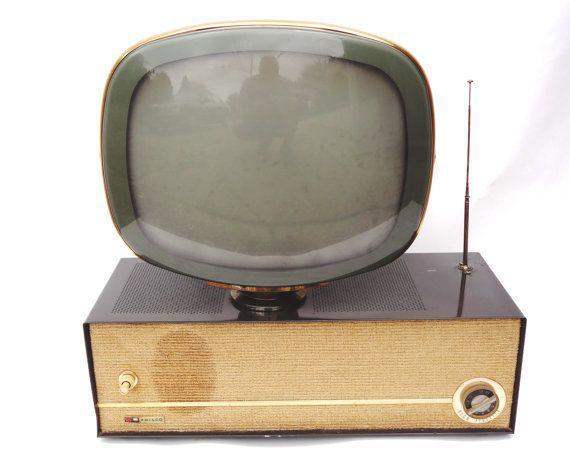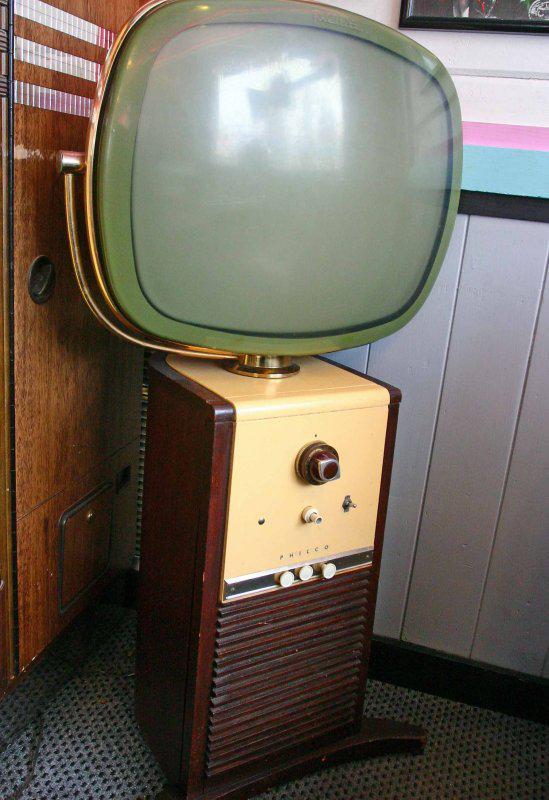The first image is the image on the left, the second image is the image on the right. Assess this claim about the two images: "There is one person next to a television". Correct or not? Answer yes or no. No. The first image is the image on the left, the second image is the image on the right. For the images displayed, is the sentence "In one of the images, there is a single person by the TV." factually correct? Answer yes or no. No. 